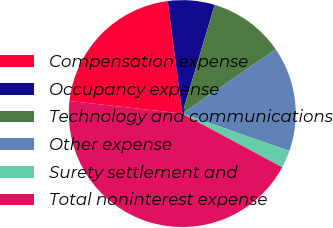Convert chart. <chart><loc_0><loc_0><loc_500><loc_500><pie_chart><fcel>Compensation expense<fcel>Occupancy expense<fcel>Technology and communications<fcel>Other expense<fcel>Surety settlement and<fcel>Total noninterest expense<nl><fcel>21.19%<fcel>6.65%<fcel>10.79%<fcel>14.93%<fcel>2.51%<fcel>43.92%<nl></chart> 